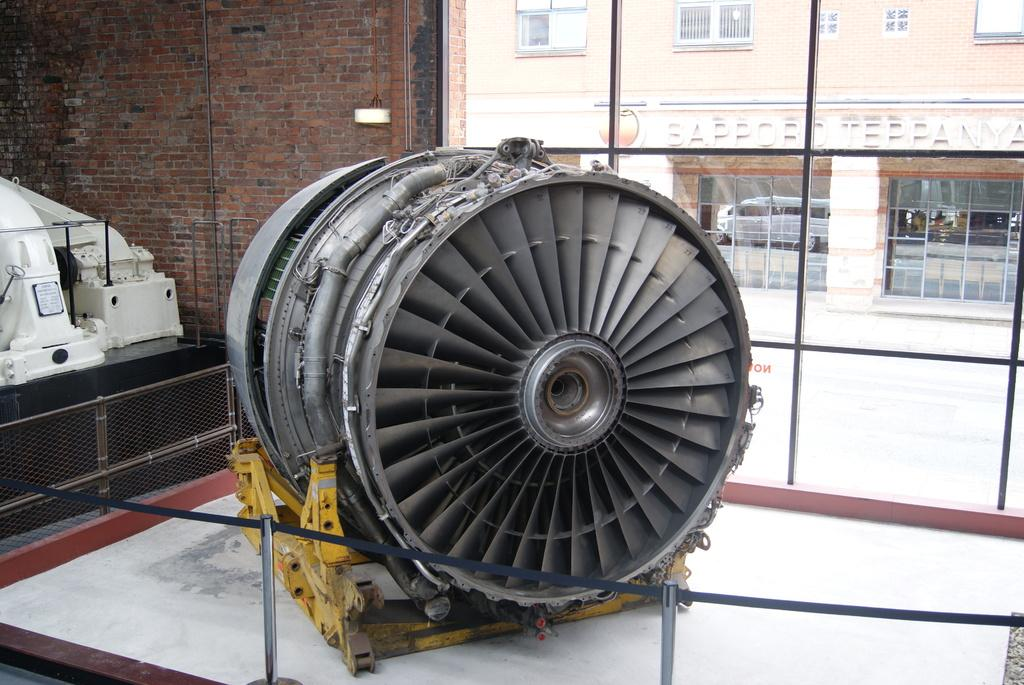What is the main subject in the center of the image? There is an object in the center of the image. What can be seen in the distance behind the object? There is a building in the background of the image. What type of structure is present in the image? There is a wall in the image. How many women are working for the company in the image? There is no reference to a company or any women in the image, so it's not possible to determine the number of women working for the company. 